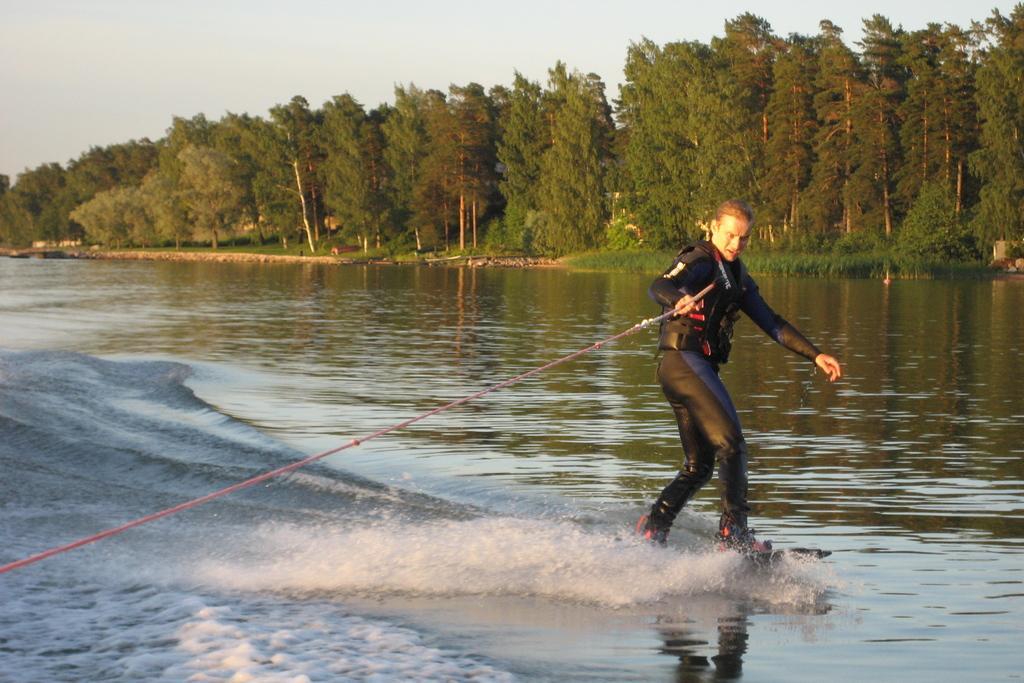Could you give a brief overview of what you see in this image? In the picture we can see a person wearing black color dress surfing on water by holding some rope in his hands and in the background there are some trees and clear sky. 